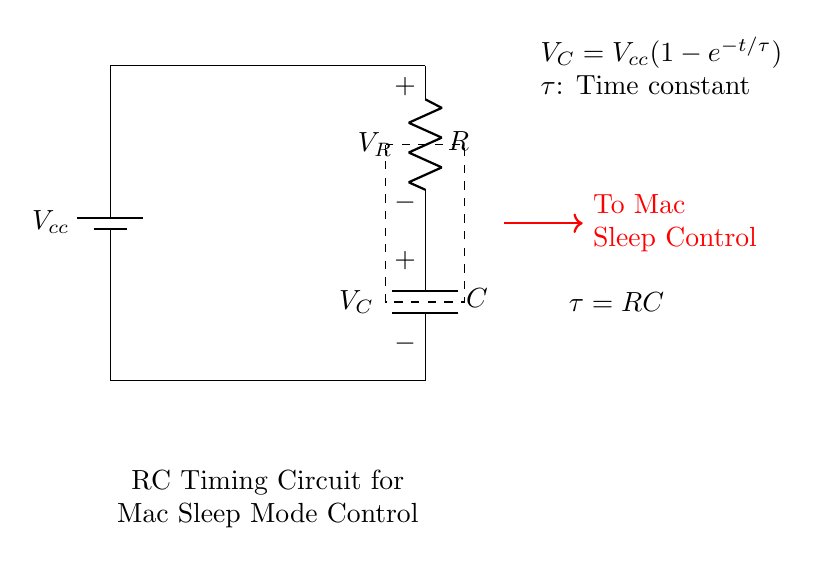What is the power supply voltage in this circuit? The circuit shows a battery labeled with 'Vcc', which indicates the power supply voltage. The specific voltage value isn't given, but it is represented as Vcc.
Answer: Vcc What are the components shown in the circuit diagram? The diagram includes a battery, a resistor, and a capacitor. These components are identified by their symbols in the diagram.
Answer: Battery, Resistor, Capacitor What is the time constant of this RC circuit? The time constant is represented by the equation element tau (τ) inside the dashed rectangle, stated as τ = RC, which shows that it is the product of the resistance and capacitance in the circuit.
Answer: RC How does the voltage across the capacitor change over time? The equation provided states that the capacitor voltage (Vc) increases over time according to the formula Vc = Vcc(1 - e^(-t/τ)). This implies the voltage rises exponentially towards the power supply voltage.
Answer: Exponentially What is the role of the capacitor in this timing circuit? The capacitor in this circuit charges over time when a voltage is applied, which is critical for creating a delay, such as controlling Mac sleep mode based on the time it takes for the capacitor to charge to a certain level.
Answer: Delay control What does the dashed rectangle signify in the circuit? The dashed rectangle marks the area where the time constant relationship (τ = RC) is given, indicating the fundamental property of how the resistor and capacitor interact to determine the timing behavior.
Answer: Time constant What does the voltage across the resistor represent? The voltage across the resistor (Vr) is indicated in the diagram, reflecting the voltage drop that occurs due to current flowing through the resistor as a function of the circuit behavior.
Answer: V_R 